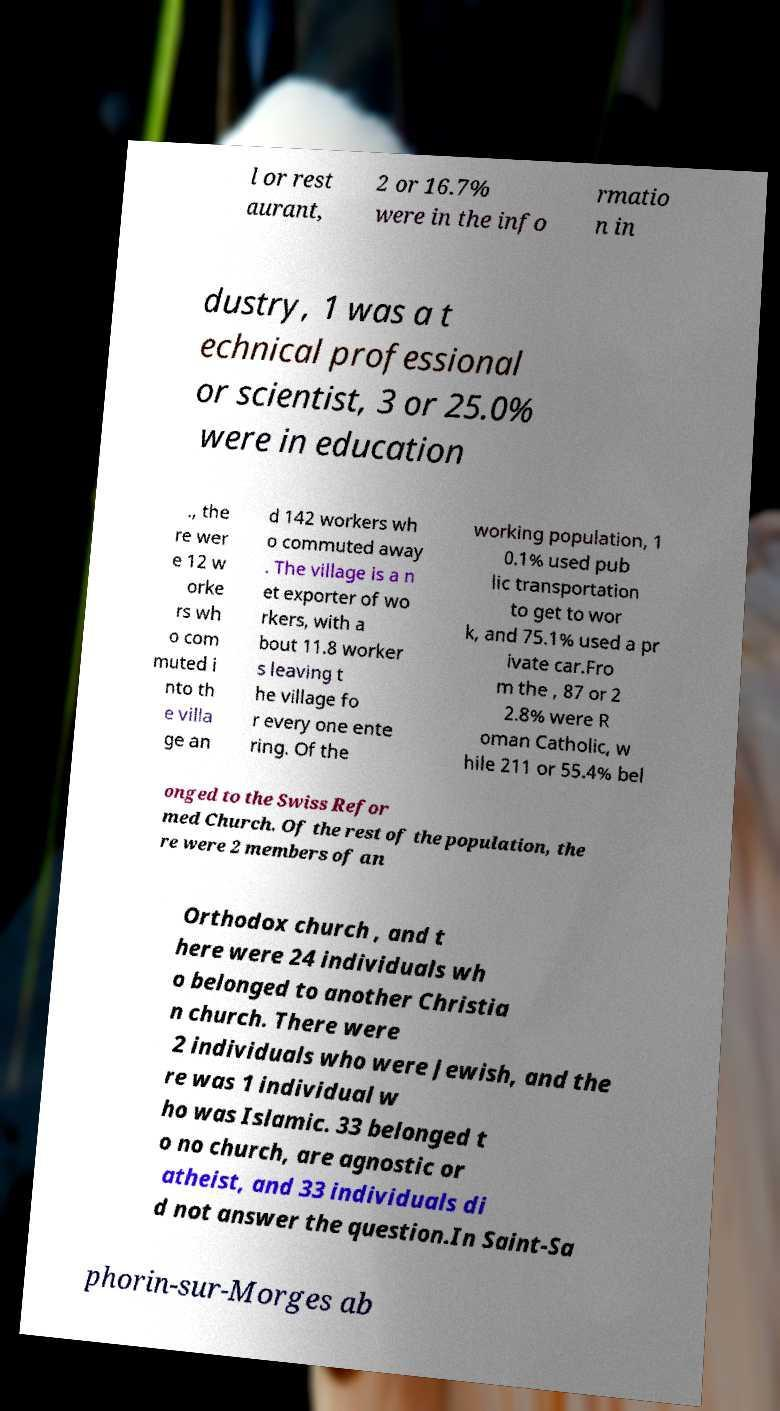Please read and relay the text visible in this image. What does it say? l or rest aurant, 2 or 16.7% were in the info rmatio n in dustry, 1 was a t echnical professional or scientist, 3 or 25.0% were in education ., the re wer e 12 w orke rs wh o com muted i nto th e villa ge an d 142 workers wh o commuted away . The village is a n et exporter of wo rkers, with a bout 11.8 worker s leaving t he village fo r every one ente ring. Of the working population, 1 0.1% used pub lic transportation to get to wor k, and 75.1% used a pr ivate car.Fro m the , 87 or 2 2.8% were R oman Catholic, w hile 211 or 55.4% bel onged to the Swiss Refor med Church. Of the rest of the population, the re were 2 members of an Orthodox church , and t here were 24 individuals wh o belonged to another Christia n church. There were 2 individuals who were Jewish, and the re was 1 individual w ho was Islamic. 33 belonged t o no church, are agnostic or atheist, and 33 individuals di d not answer the question.In Saint-Sa phorin-sur-Morges ab 